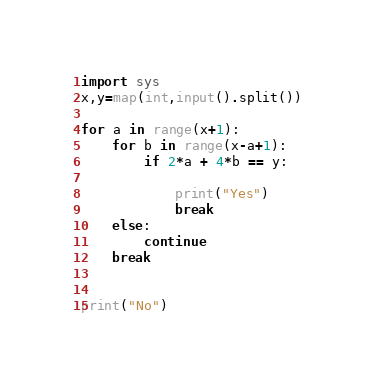<code> <loc_0><loc_0><loc_500><loc_500><_Python_>import sys
x,y=map(int,input().split())

for a in range(x+1):
	for b in range(x-a+1):
		if 2*a + 4*b == y:
			
			print("Yes")
			break
	else:
		continue
	break

            
print("No")</code> 